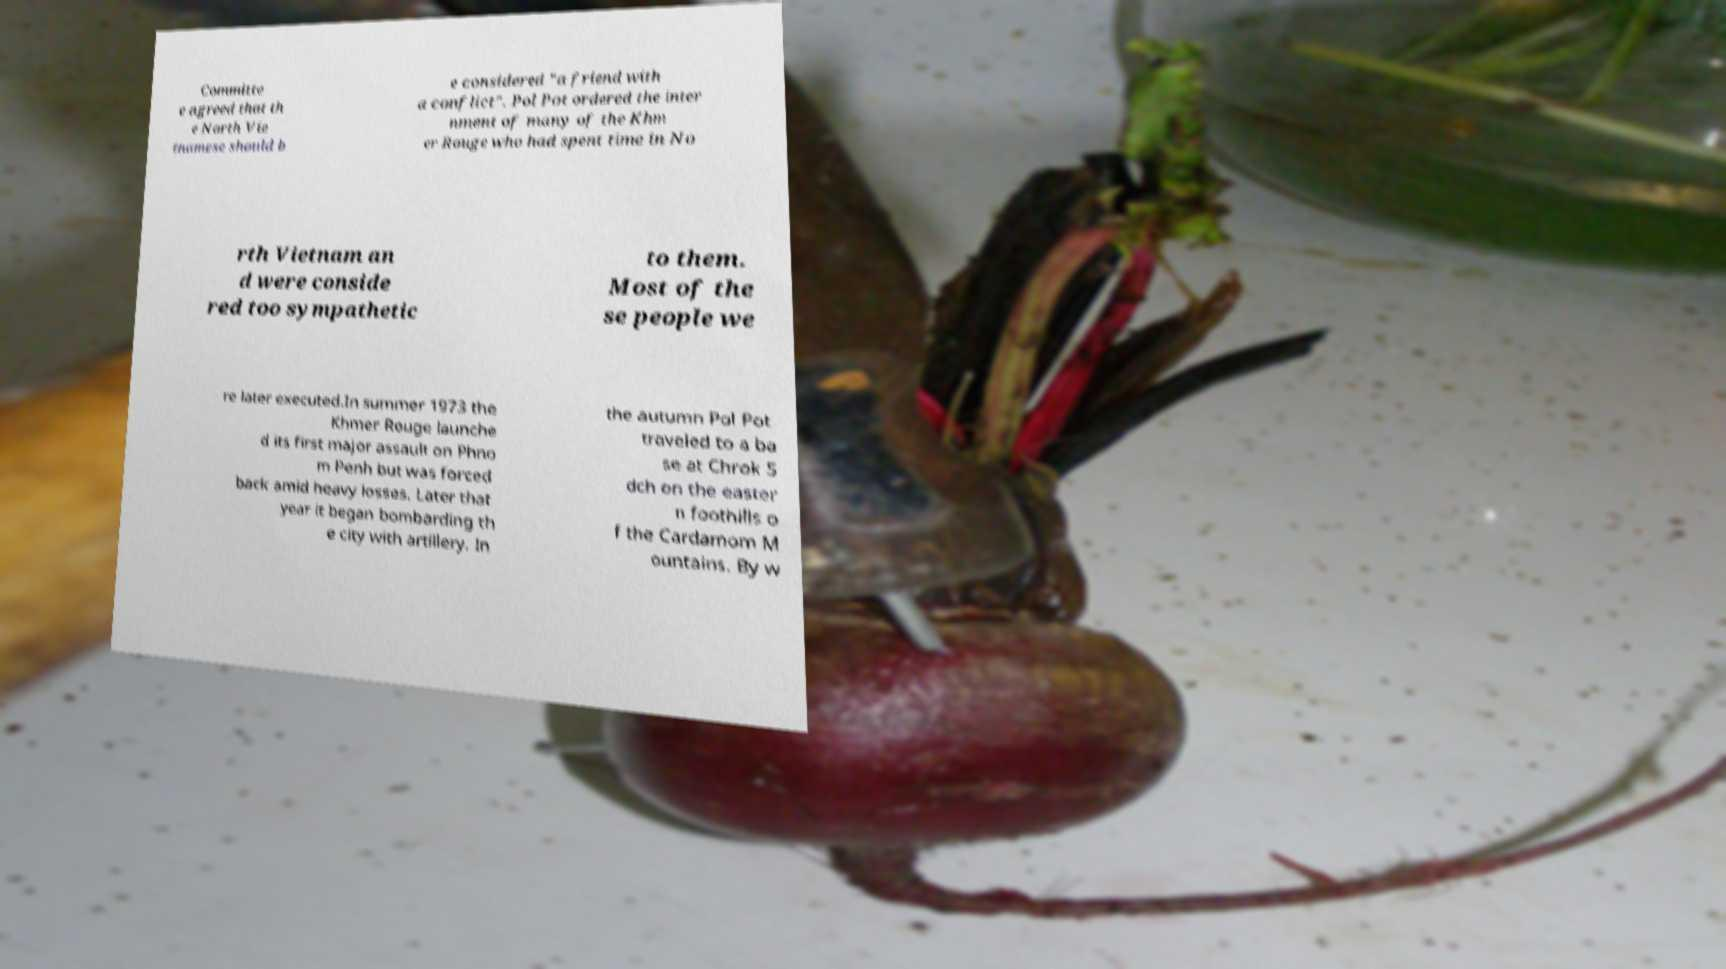What messages or text are displayed in this image? I need them in a readable, typed format. Committe e agreed that th e North Vie tnamese should b e considered "a friend with a conflict". Pol Pot ordered the inter nment of many of the Khm er Rouge who had spent time in No rth Vietnam an d were conside red too sympathetic to them. Most of the se people we re later executed.In summer 1973 the Khmer Rouge launche d its first major assault on Phno m Penh but was forced back amid heavy losses. Later that year it began bombarding th e city with artillery. In the autumn Pol Pot traveled to a ba se at Chrok S dch on the easter n foothills o f the Cardamom M ountains. By w 